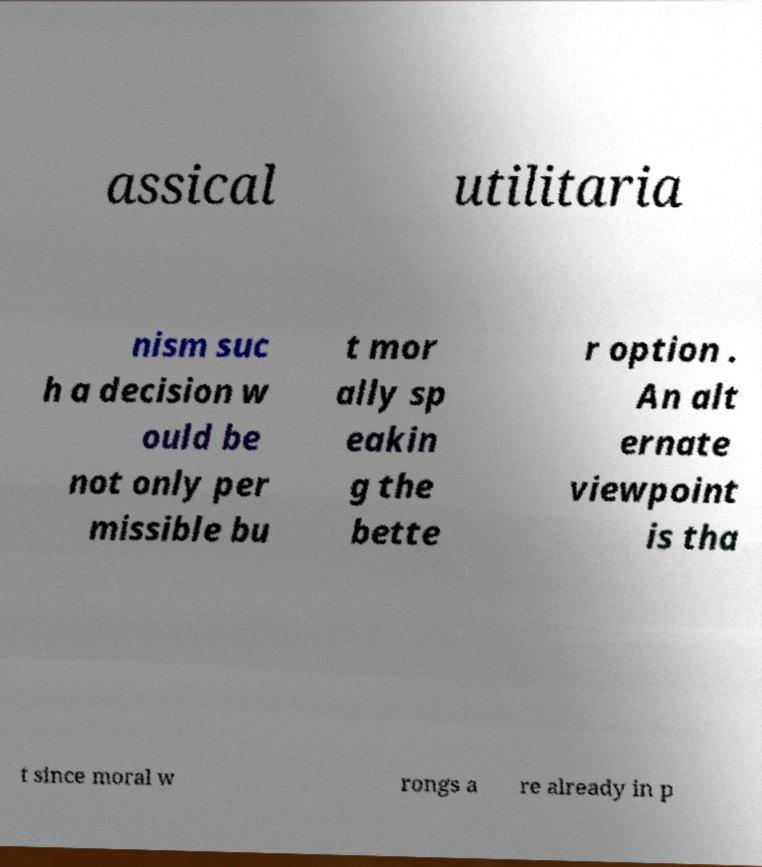Please read and relay the text visible in this image. What does it say? assical utilitaria nism suc h a decision w ould be not only per missible bu t mor ally sp eakin g the bette r option . An alt ernate viewpoint is tha t since moral w rongs a re already in p 